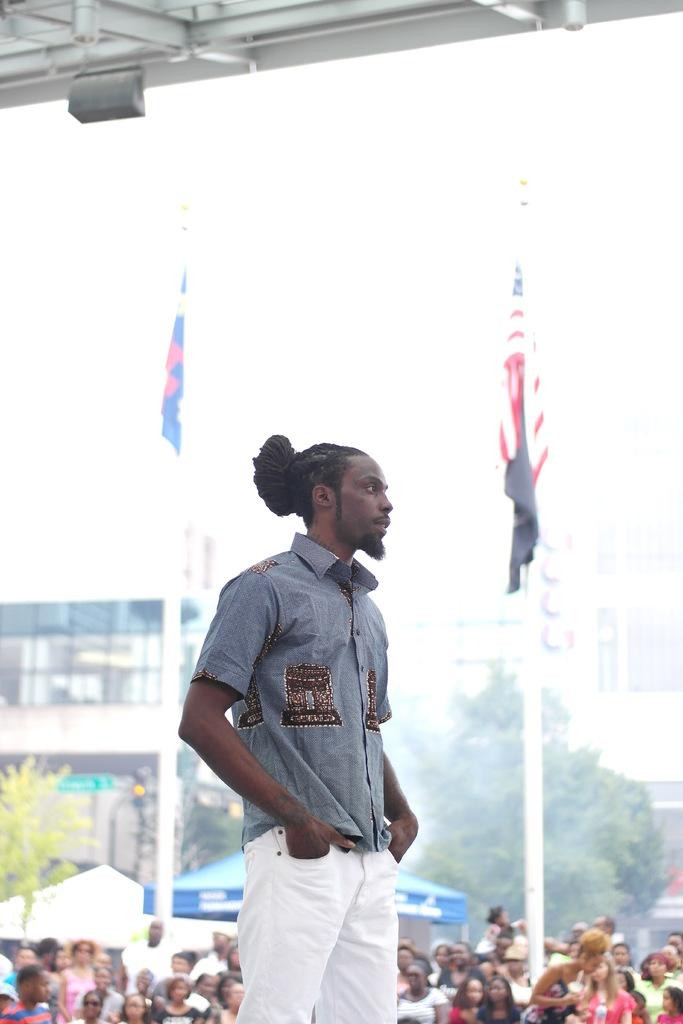What is the main subject of the image? There is a man standing in the image. What else can be seen in the image besides the man? There are flags with poles, a group of people, canopy tents, buildings, and trees in the image. How many trains can be seen in the image? There are no trains present in the image. What type of crowd is gathered around the man in the image? There is no crowd gathered around the man in the image; there is just a group of people. 